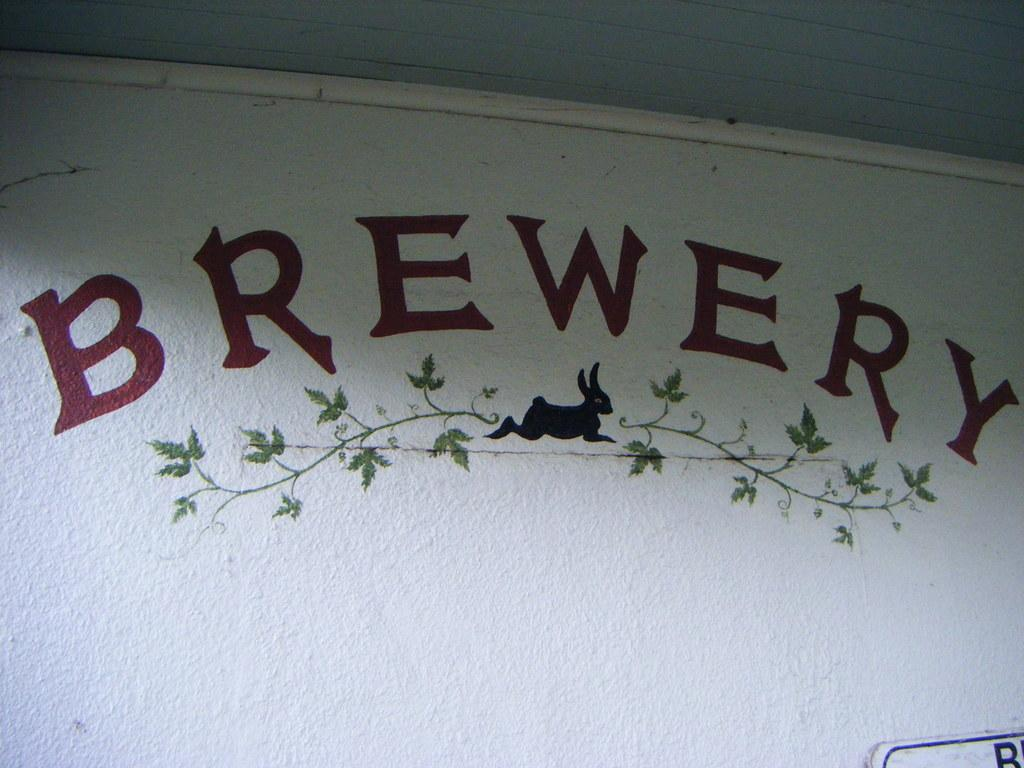What is present on the wall in the image? There is writing on the wall in the image. What else can be seen in the image besides the wall? There is a rabbit in the image. What type of wire is being used to hold the rabbit in the image? There is no wire present in the image; the rabbit is not being held by any wire. 